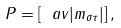Convert formula to latex. <formula><loc_0><loc_0><loc_500><loc_500>P = [ \ a v { | m _ { \sigma \tau } | } ] \, ,</formula> 